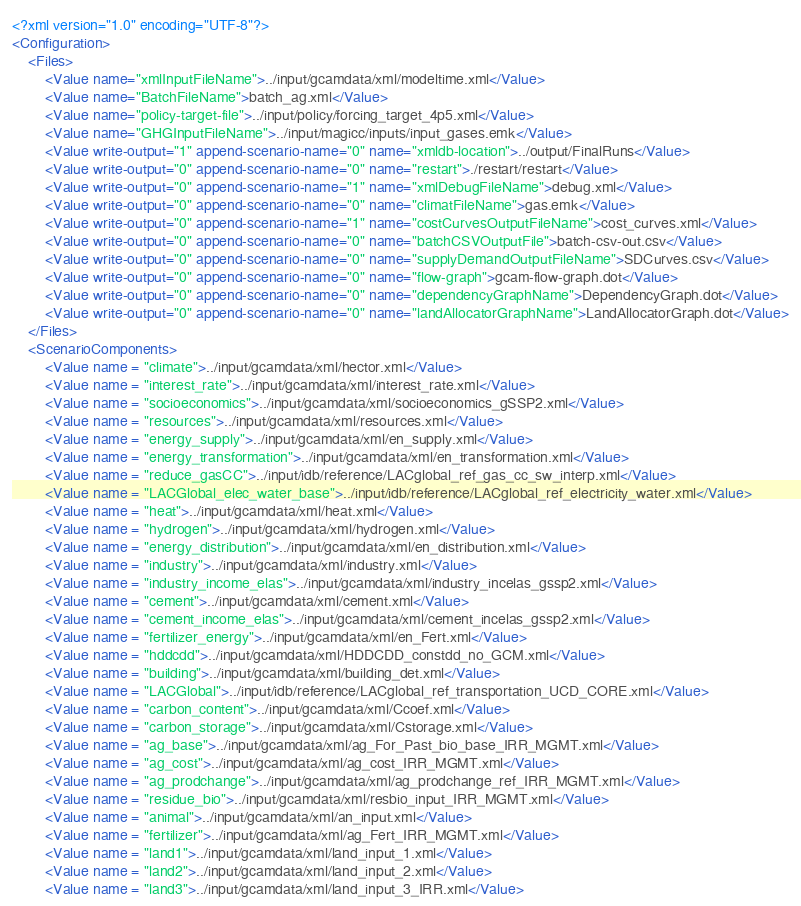Convert code to text. <code><loc_0><loc_0><loc_500><loc_500><_XML_><?xml version="1.0" encoding="UTF-8"?>
<Configuration>
	<Files>
		<Value name="xmlInputFileName">../input/gcamdata/xml/modeltime.xml</Value>
		<Value name="BatchFileName">batch_ag.xml</Value>
		<Value name="policy-target-file">../input/policy/forcing_target_4p5.xml</Value>
		<Value name="GHGInputFileName">../input/magicc/inputs/input_gases.emk</Value>
		<Value write-output="1" append-scenario-name="0" name="xmldb-location">../output/FinalRuns</Value>
		<Value write-output="0" append-scenario-name="0" name="restart">./restart/restart</Value>
		<Value write-output="0" append-scenario-name="1" name="xmlDebugFileName">debug.xml</Value>
		<Value write-output="0" append-scenario-name="0" name="climatFileName">gas.emk</Value>
		<Value write-output="0" append-scenario-name="1" name="costCurvesOutputFileName">cost_curves.xml</Value>
		<Value write-output="0" append-scenario-name="0" name="batchCSVOutputFile">batch-csv-out.csv</Value>
		<Value write-output="0" append-scenario-name="0" name="supplyDemandOutputFileName">SDCurves.csv</Value>
		<Value write-output="0" append-scenario-name="0" name="flow-graph">gcam-flow-graph.dot</Value>
		<Value write-output="0" append-scenario-name="0" name="dependencyGraphName">DependencyGraph.dot</Value>
		<Value write-output="0" append-scenario-name="0" name="landAllocatorGraphName">LandAllocatorGraph.dot</Value>
	</Files>
	<ScenarioComponents>
        <Value name = "climate">../input/gcamdata/xml/hector.xml</Value>
		<Value name = "interest_rate">../input/gcamdata/xml/interest_rate.xml</Value>
		<Value name = "socioeconomics">../input/gcamdata/xml/socioeconomics_gSSP2.xml</Value>
		<Value name = "resources">../input/gcamdata/xml/resources.xml</Value>
		<Value name = "energy_supply">../input/gcamdata/xml/en_supply.xml</Value>
		<Value name = "energy_transformation">../input/gcamdata/xml/en_transformation.xml</Value>
		<Value name = "reduce_gasCC">../input/idb/reference/LACglobal_ref_gas_cc_sw_interp.xml</Value>
		<Value name = "LACGlobal_elec_water_base">../input/idb/reference/LACglobal_ref_electricity_water.xml</Value>
		<Value name = "heat">../input/gcamdata/xml/heat.xml</Value>
		<Value name = "hydrogen">../input/gcamdata/xml/hydrogen.xml</Value>
		<Value name = "energy_distribution">../input/gcamdata/xml/en_distribution.xml</Value>
		<Value name = "industry">../input/gcamdata/xml/industry.xml</Value>
		<Value name = "industry_income_elas">../input/gcamdata/xml/industry_incelas_gssp2.xml</Value>
		<Value name = "cement">../input/gcamdata/xml/cement.xml</Value>
		<Value name = "cement_income_elas">../input/gcamdata/xml/cement_incelas_gssp2.xml</Value>
		<Value name = "fertilizer_energy">../input/gcamdata/xml/en_Fert.xml</Value>
		<Value name = "hddcdd">../input/gcamdata/xml/HDDCDD_constdd_no_GCM.xml</Value>
		<Value name = "building">../input/gcamdata/xml/building_det.xml</Value>
		<Value name = "LACGlobal">../input/idb/reference/LACglobal_ref_transportation_UCD_CORE.xml</Value>
		<Value name = "carbon_content">../input/gcamdata/xml/Ccoef.xml</Value>
		<Value name = "carbon_storage">../input/gcamdata/xml/Cstorage.xml</Value>
		<Value name = "ag_base">../input/gcamdata/xml/ag_For_Past_bio_base_IRR_MGMT.xml</Value>
		<Value name = "ag_cost">../input/gcamdata/xml/ag_cost_IRR_MGMT.xml</Value>
		<Value name = "ag_prodchange">../input/gcamdata/xml/ag_prodchange_ref_IRR_MGMT.xml</Value>
		<Value name = "residue_bio">../input/gcamdata/xml/resbio_input_IRR_MGMT.xml</Value>
		<Value name = "animal">../input/gcamdata/xml/an_input.xml</Value>
		<Value name = "fertilizer">../input/gcamdata/xml/ag_Fert_IRR_MGMT.xml</Value>
		<Value name = "land1">../input/gcamdata/xml/land_input_1.xml</Value>
		<Value name = "land2">../input/gcamdata/xml/land_input_2.xml</Value>
		<Value name = "land3">../input/gcamdata/xml/land_input_3_IRR.xml</Value></code> 